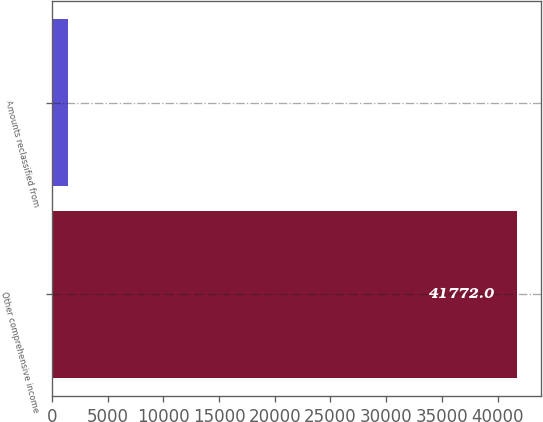Convert chart to OTSL. <chart><loc_0><loc_0><loc_500><loc_500><bar_chart><fcel>Other comprehensive income<fcel>Amounts reclassified from<nl><fcel>41772<fcel>1428<nl></chart> 